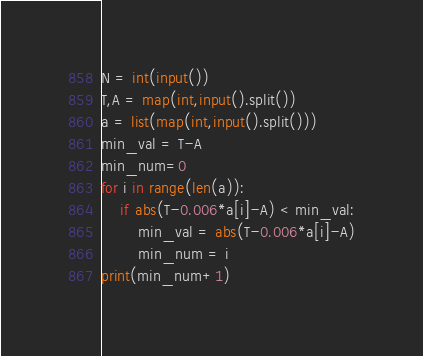Convert code to text. <code><loc_0><loc_0><loc_500><loc_500><_Python_>N = int(input())
T,A = map(int,input().split())
a = list(map(int,input().split()))
min_val = T-A
min_num=0
for i in range(len(a)):
    if abs(T-0.006*a[i]-A) < min_val:
        min_val = abs(T-0.006*a[i]-A)
        min_num = i
print(min_num+1)</code> 